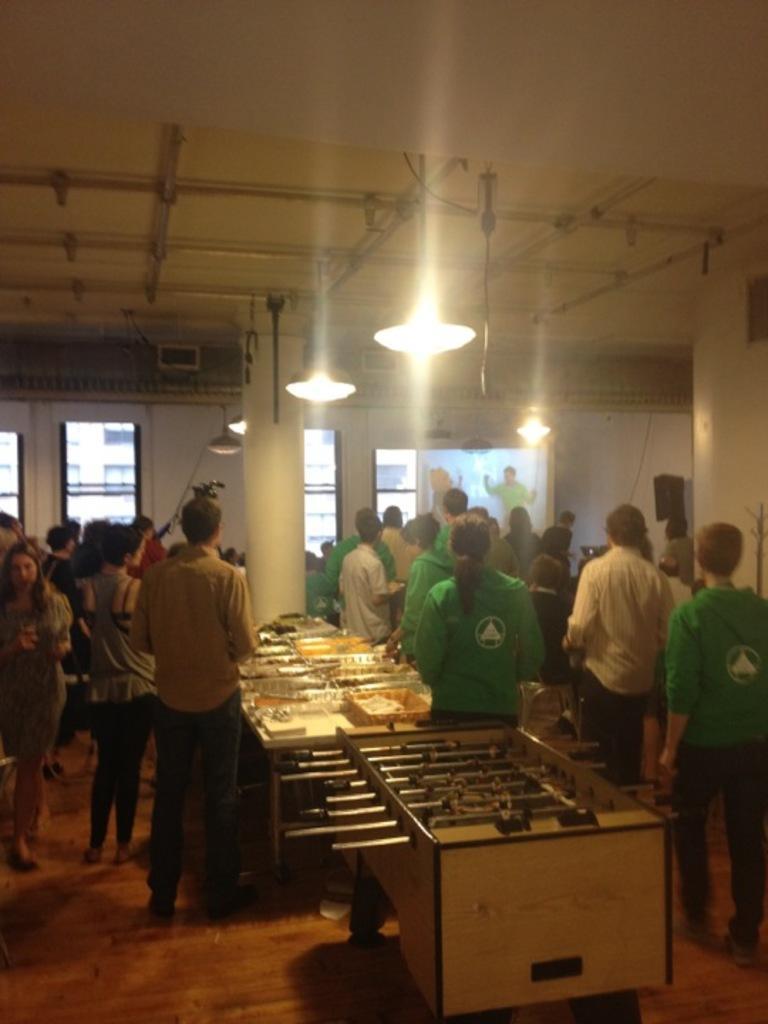Please provide a concise description of this image. In this image there are group of people who are standing. on the top there is ceiling and some lights are there and in the middle there are some tables and in the background there are some glass windows are there. 